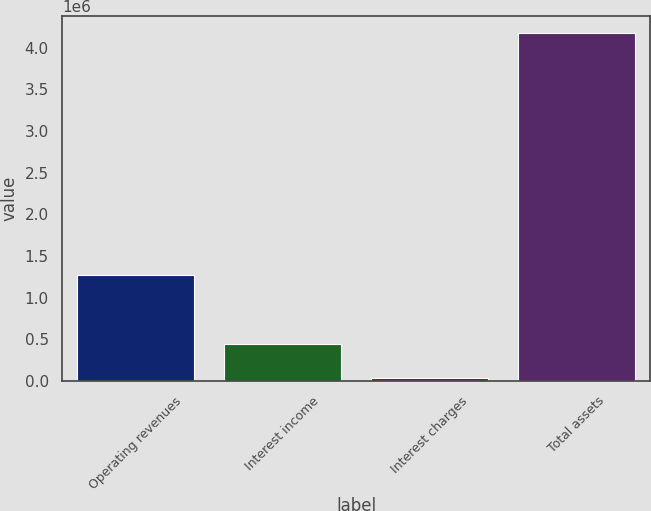Convert chart. <chart><loc_0><loc_0><loc_500><loc_500><bar_chart><fcel>Operating revenues<fcel>Interest income<fcel>Interest charges<fcel>Total assets<nl><fcel>1.27498e+06<fcel>448192<fcel>34460<fcel>4.17178e+06<nl></chart> 